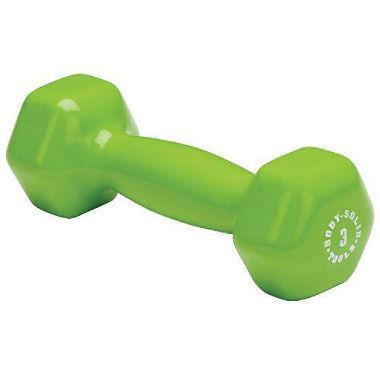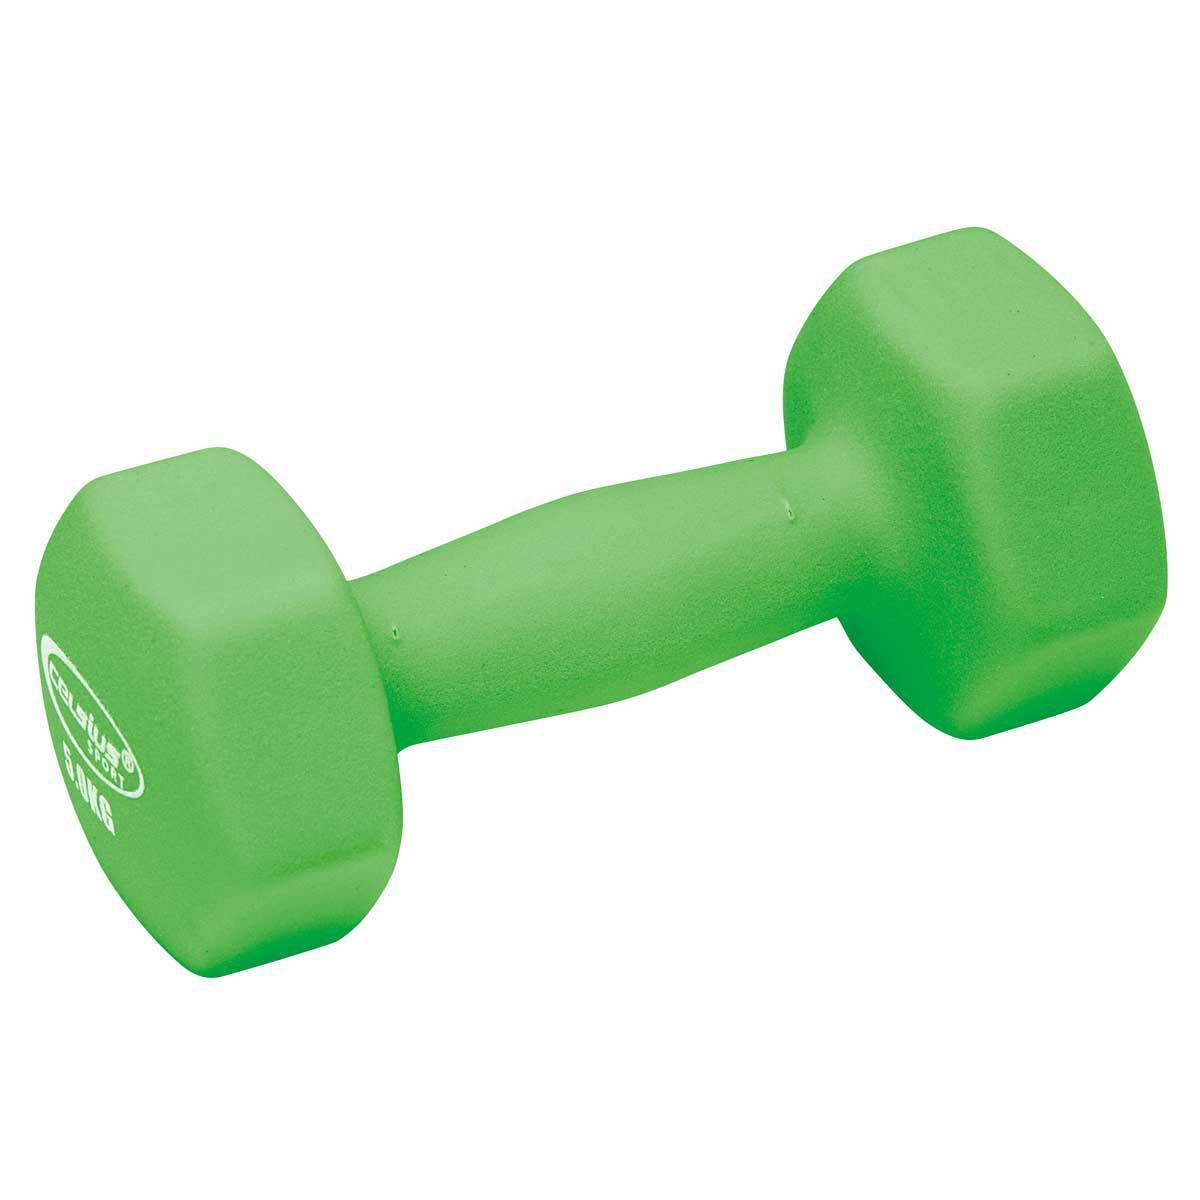The first image is the image on the left, the second image is the image on the right. Considering the images on both sides, is "Images contain green dumbbells and contain the same number of dumbbells." valid? Answer yes or no. Yes. The first image is the image on the left, the second image is the image on the right. Considering the images on both sides, is "All of the weights are green in both images." valid? Answer yes or no. Yes. 